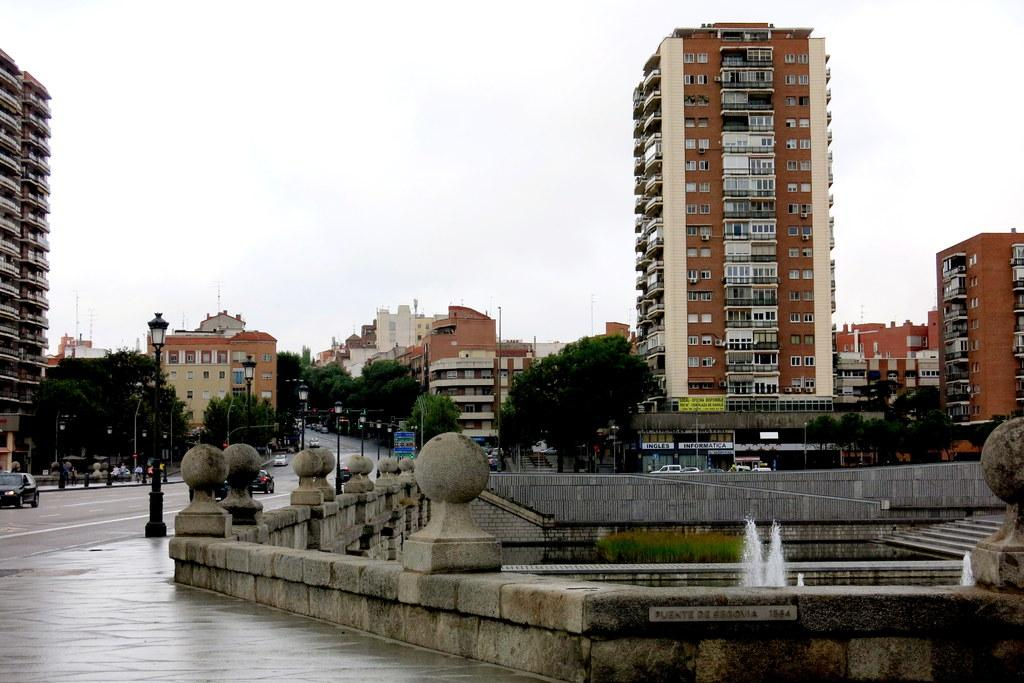What types of structures are present in the image? There are houses and buildings in the image. What natural elements can be seen in the image? There are trees and plants in the image. What man-made feature is present in the image? There is a water fountain in the image. Can you describe the general setting of the image? The image features a combination of natural and man-made elements, including houses, buildings, trees, plants, and a water fountain. How many ducks are sitting on the fan in the image? There are no ducks or fans present in the image. What causes the water fountain to stop in the image? The image does not show the water fountain stopping, nor does it provide any information about the water fountain's operation. 